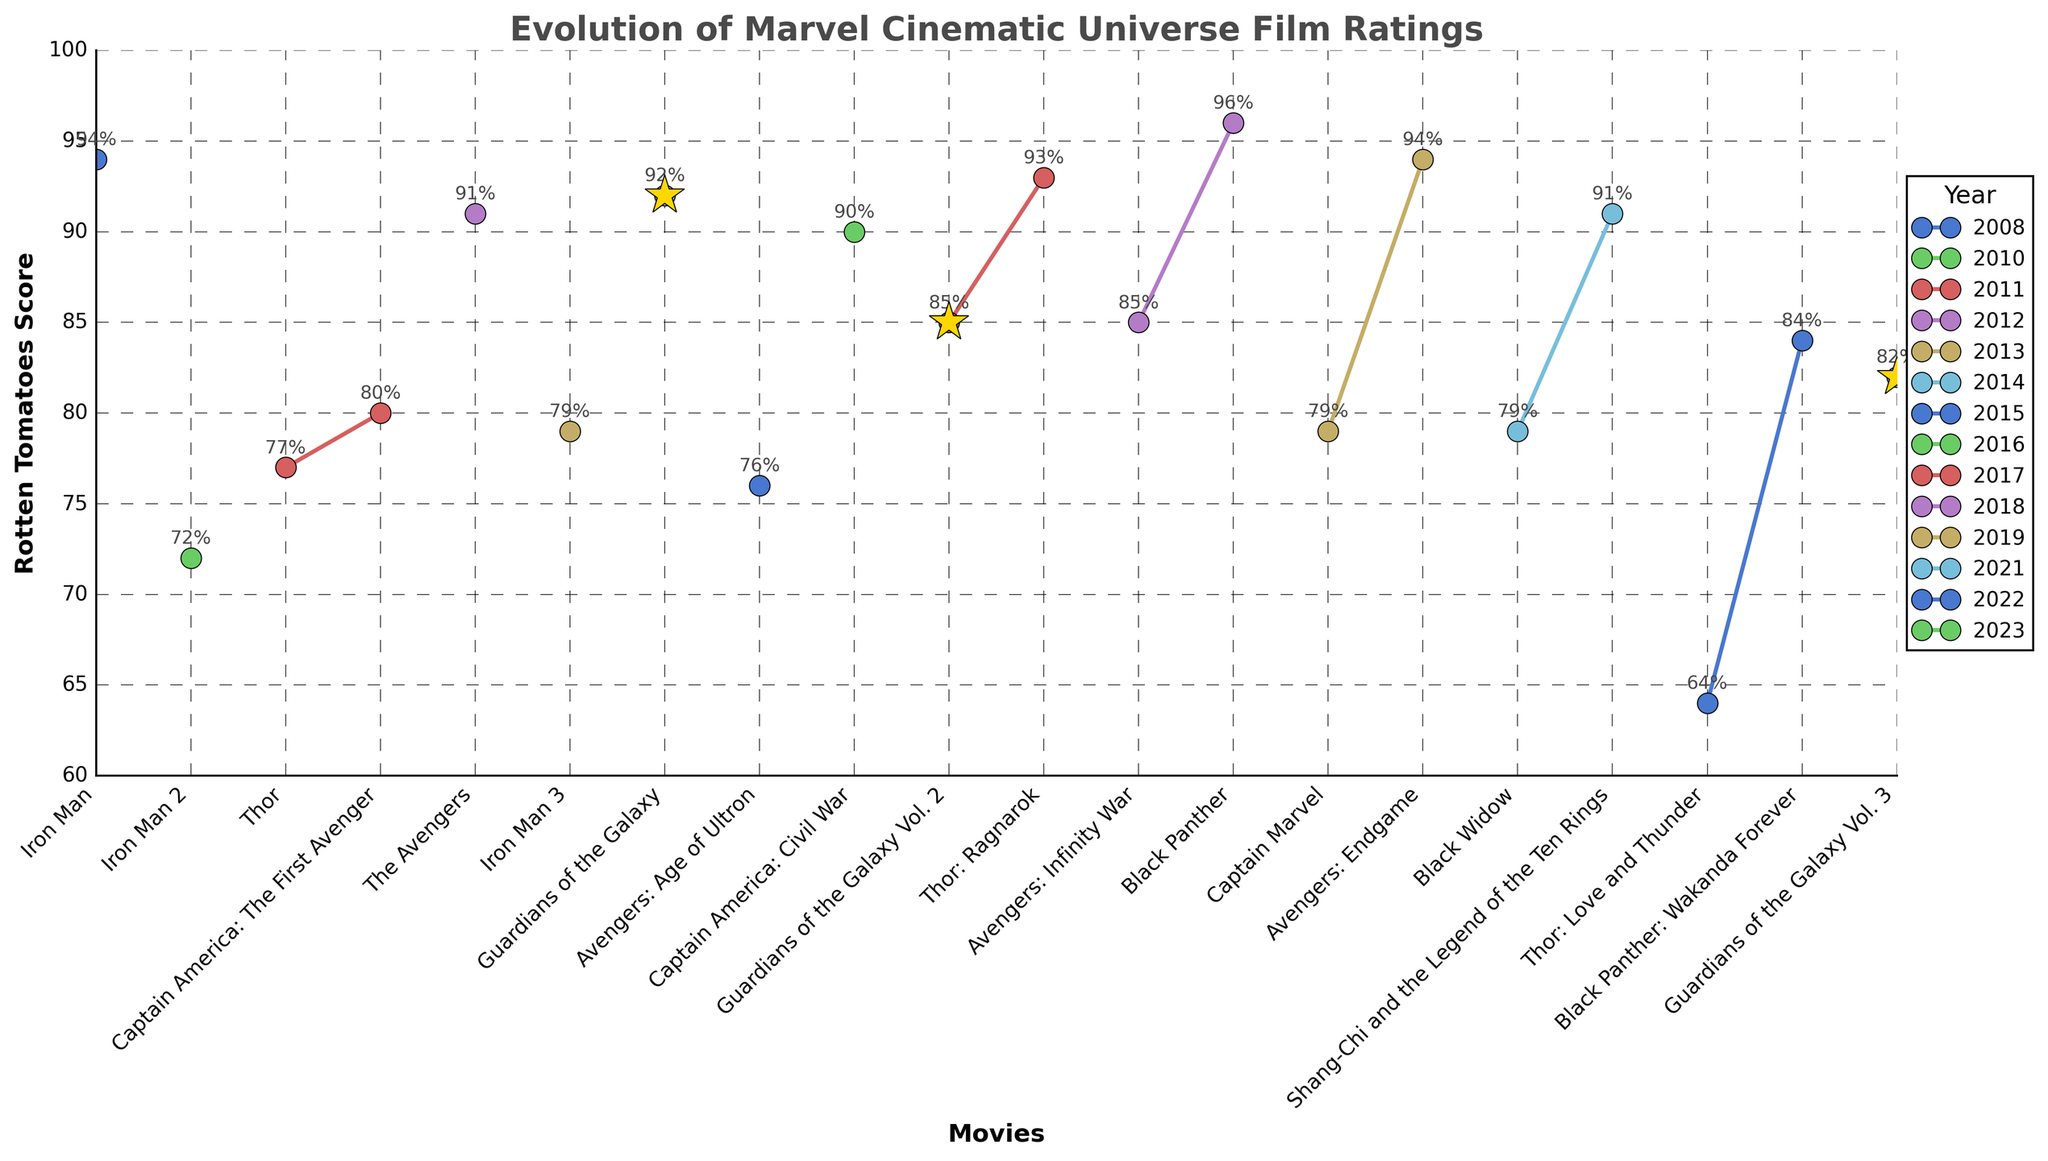What was the highest Rotten Tomatoes score for a Marvel movie from 2008 to 2023? Look at the y-axis values and identify the highest point on the line chart, which corresponds to "Black Panther" (2018) with a score of 96%.
Answer: 96% Which two movies released in the same year had the biggest difference in Rotten Tomatoes scores? Identify years with multiple releases, compare the scores, and find the highest difference. In 2022, "Thor: Love and Thunder" scored 64% and "Black Panther: Wakanda Forever" scored 84%, yielding a difference of 20%.
Answer: Thor: Love and Thunder; Black Panther: Wakanda Forever How did the ratings for the Guardians of the Galaxy movies change over time? Observe the points marked with stars and compare their scores: "Guardians of the Galaxy" (2014) scored 92%, "Guardians of the Galaxy Vol. 2" (2017) scored 85%, and "Guardians of the Galaxy Vol. 3" (2023) scored 82%.
Answer: Decreased Which movie had a lower Rotten Tomatoes score: "Iron Man 2" or "Avengers: Age of Ultron"? Find both movies on the x-axis; "Iron Man 2" (2010) scored 72% and "Avengers: Age of Ultron" (2015) scored 76%.
Answer: Iron Man 2 What is the average Rotten Tomatoes score of all movies released after 2019? Identify all movies after 2019, sum their scores and divide by the number of movies: (79 + 91 + 64 + 84 + 82) / 5. The result is (79+91+64+84+82) = 400, and 400/5 = 80.
Answer: 80 Which movie recorded a higher score on Rotten Tomatoes, "The Avengers" or "Avengers: Infinity War"? Compare the scores for the two movies; "The Avengers" (2012) scored 91%, while "Avengers: Infinity War" (2018) scored 85%.
Answer: The Avengers In which year was the highest number of Marvel movies released, and what were their scores? Count movie releases per year and note their scores. The year 2022 had the most, with "Thor: Love and Thunder" (64%) and "Black Panther: Wakanda Forever" (84%).
Answer: 2022; 64%, 84% What is the score difference between the best-rated and worst-rated movies from 2008 to 2023? Identify the highest (96% for "Black Panther") and lowest (64% for "Thor: Love and Thunder") scores and calculate the difference: 96% - 64% = 32%.
Answer: 32% Between "Thor: Ragnarok" and "Thor: Love and Thunder," which movie had a better rating and by how much? Compare the Rotten Tomatoes scores for both movies: "Thor: Ragnarok" scored 93% and "Thor: Love and Thunder" scored 64%, with a difference of 93% - 64% = 29%.
Answer: Thor: Ragnarok; 29% 